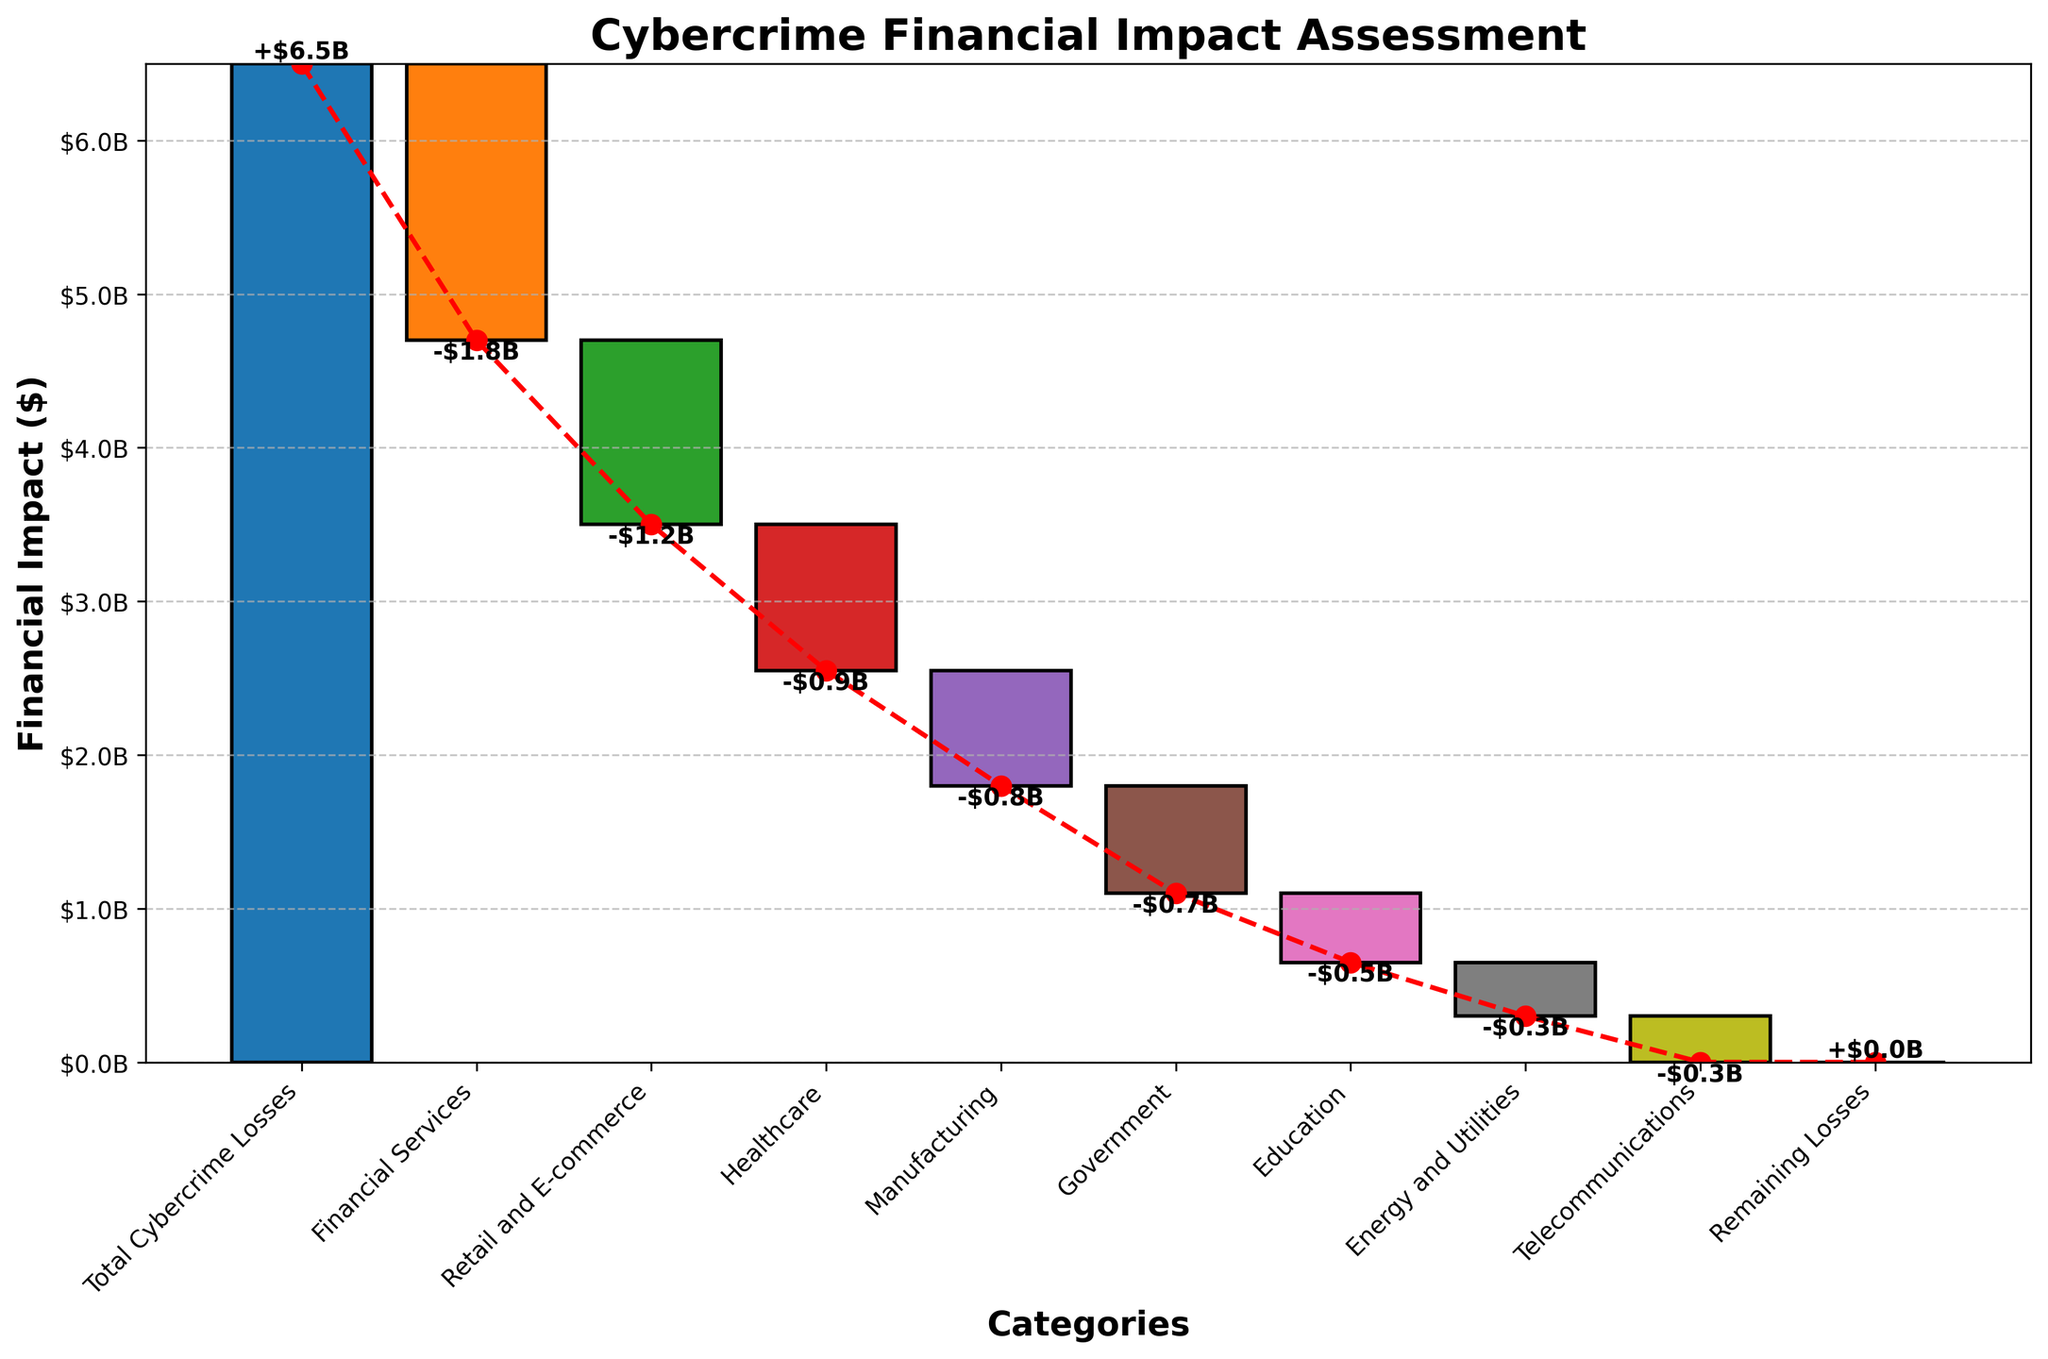What is the title of the chart? The title is located at the top of the chart and is typically the largest text.
Answer: Cybercrime Financial Impact Assessment How many categories are included in the chart? Count the number of distinct labels along the x-axis.
Answer: 10 Which sector has the highest financial loss due to cybercrime? Identify the bar with the largest negative value (most left).
Answer: Financial Services What is the total financial impact of cybercrime losses in the figure? Read the label associated with the bar representing the total cumulative loss (first bar).
Answer: $6.5B How do the losses in Retail and E-commerce compare to those in Healthcare? Compare the values associated with Retail and E-commerce and Healthcare sectors.
Answer: Retail and E-commerce losses are $1.2B, and Healthcare losses are $0.95B; Retail and E-commerce losses are higher What is the sum of losses in Manufacturing and Government sectors? Add the values of Manufacturing and Government losses.
Answer: $750M + $700M = $1.45B By how much do the losses in Financial Services exceed those in Telecommunications? Subtract the value of losses in Telecommunications from the value of Financial Services.
Answer: $1.8B - $300M = $1.5B What is the cumulative total at the end of the chart? Read the value at the end of the cumulative line (red dashed line).
Answer: $0 Which category has the smallest financial loss and what is that value? Identify the bar with the smallest negative value and read the corresponding label.
Answer: Telecommunications, $300M What is the combined financial loss in the Education and Energy and Utilities sectors? Sum the losses in the Education sector and Energy and Utilities sector.
Answer: $450M + $350M = $800M 